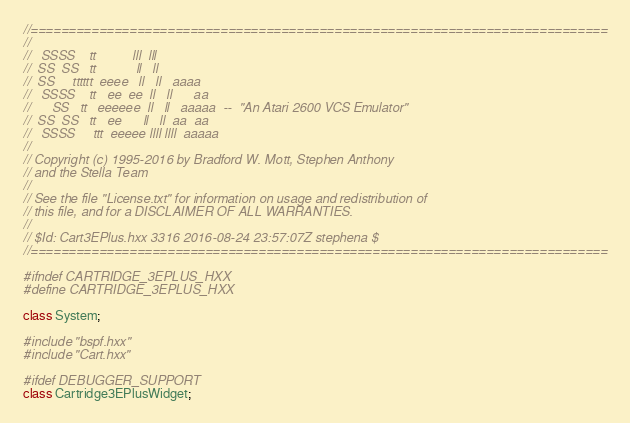<code> <loc_0><loc_0><loc_500><loc_500><_C++_>//============================================================================
//
//   SSSS    tt          lll  lll       
//  SS  SS   tt           ll   ll        
//  SS     tttttt  eeee   ll   ll   aaaa 
//   SSSS    tt   ee  ee  ll   ll      aa
//      SS   tt   eeeeee  ll   ll   aaaaa  --  "An Atari 2600 VCS Emulator"
//  SS  SS   tt   ee      ll   ll  aa  aa
//   SSSS     ttt  eeeee llll llll  aaaaa
//
// Copyright (c) 1995-2016 by Bradford W. Mott, Stephen Anthony
// and the Stella Team
//
// See the file "License.txt" for information on usage and redistribution of
// this file, and for a DISCLAIMER OF ALL WARRANTIES.
//
// $Id: Cart3EPlus.hxx 3316 2016-08-24 23:57:07Z stephena $
//============================================================================

#ifndef CARTRIDGE_3EPLUS_HXX
#define CARTRIDGE_3EPLUS_HXX

class System;

#include "bspf.hxx"
#include "Cart.hxx"

#ifdef DEBUGGER_SUPPORT
class Cartridge3EPlusWidget;</code> 